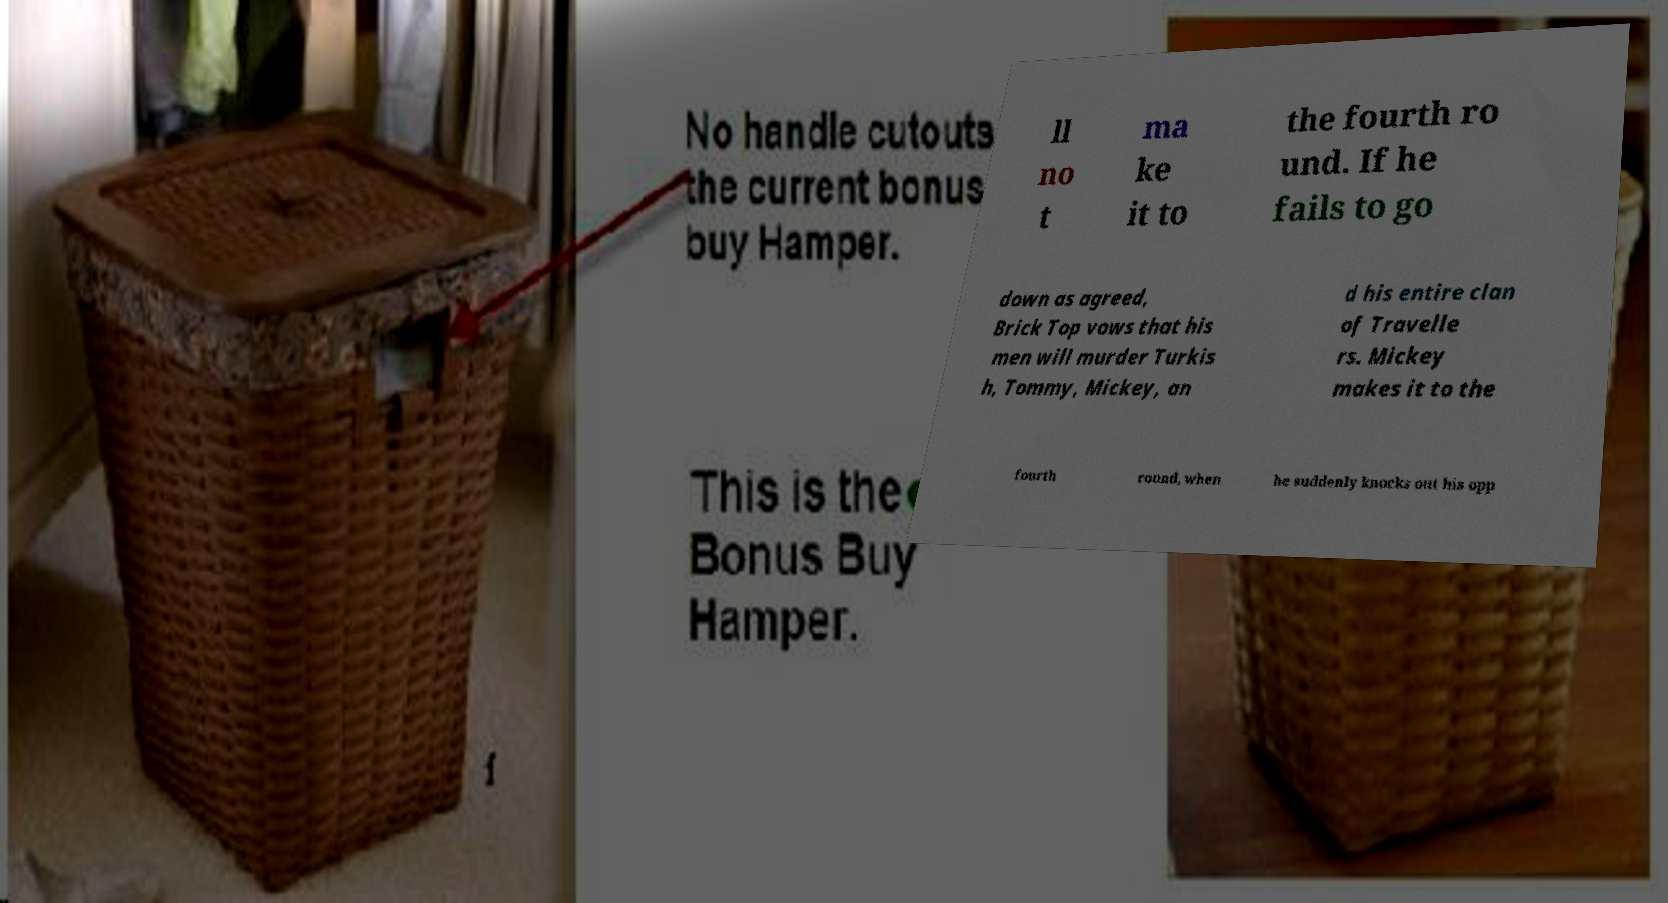Could you extract and type out the text from this image? ll no t ma ke it to the fourth ro und. If he fails to go down as agreed, Brick Top vows that his men will murder Turkis h, Tommy, Mickey, an d his entire clan of Travelle rs. Mickey makes it to the fourth round, when he suddenly knocks out his opp 